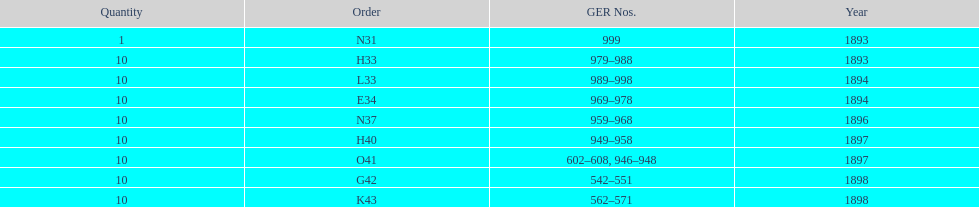How mans years have ger nos below 900? 2. 